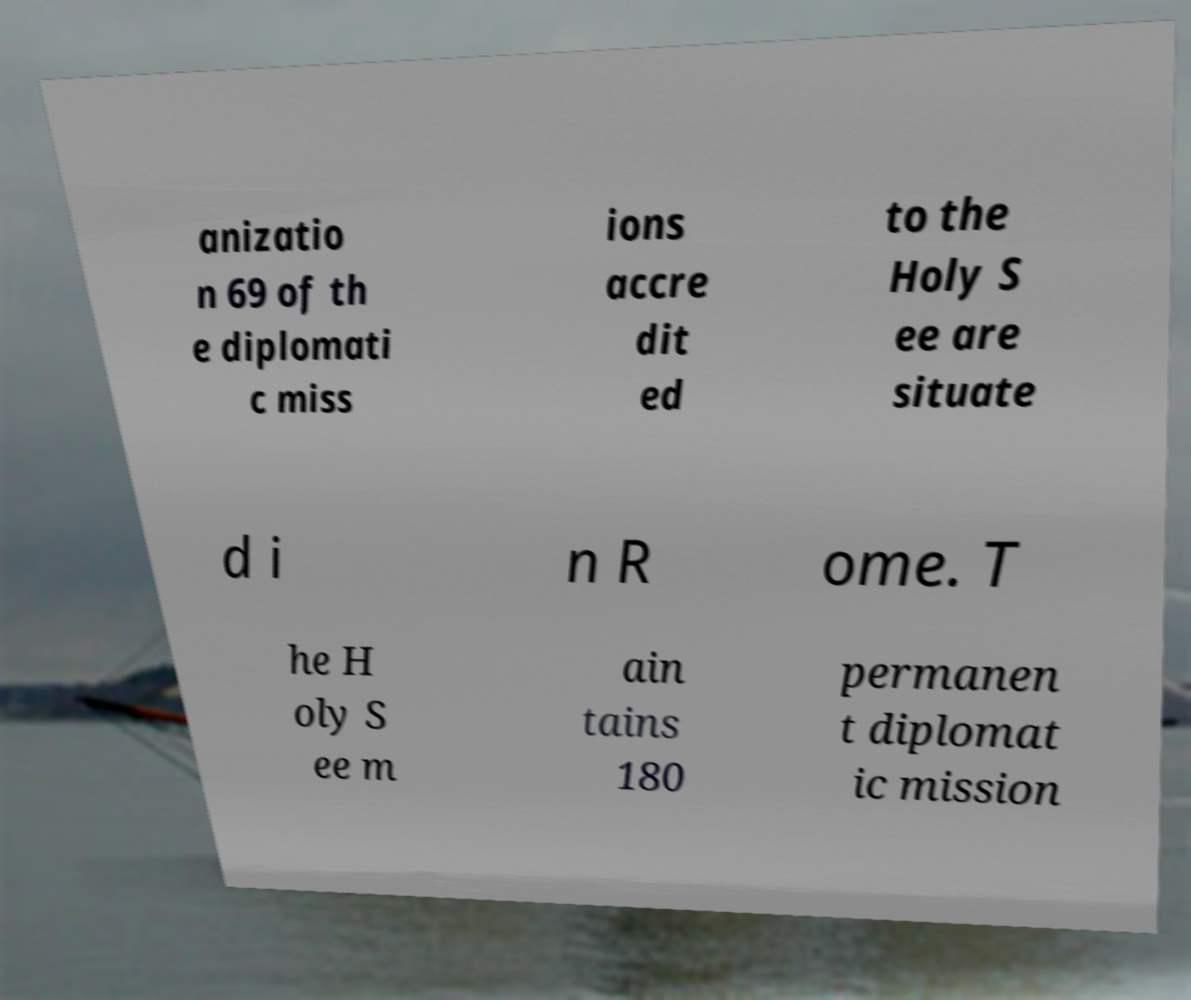Can you accurately transcribe the text from the provided image for me? anizatio n 69 of th e diplomati c miss ions accre dit ed to the Holy S ee are situate d i n R ome. T he H oly S ee m ain tains 180 permanen t diplomat ic mission 